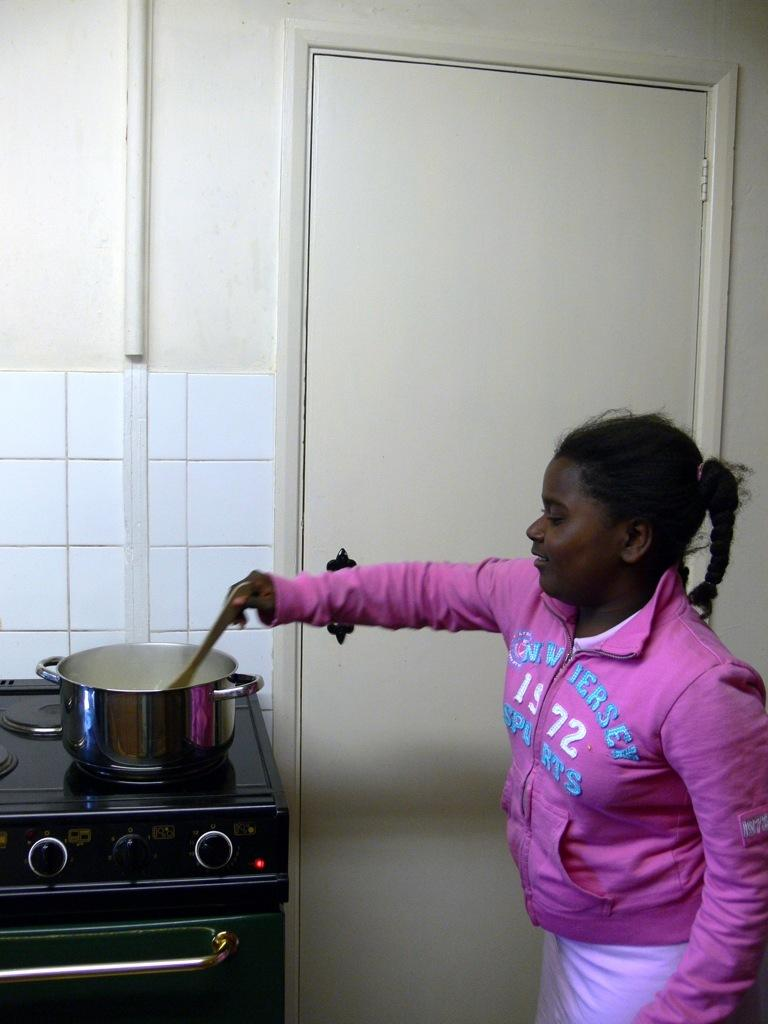<image>
Present a compact description of the photo's key features. A girl stirs a pot while wearing a shirt that says 1972 on it. 